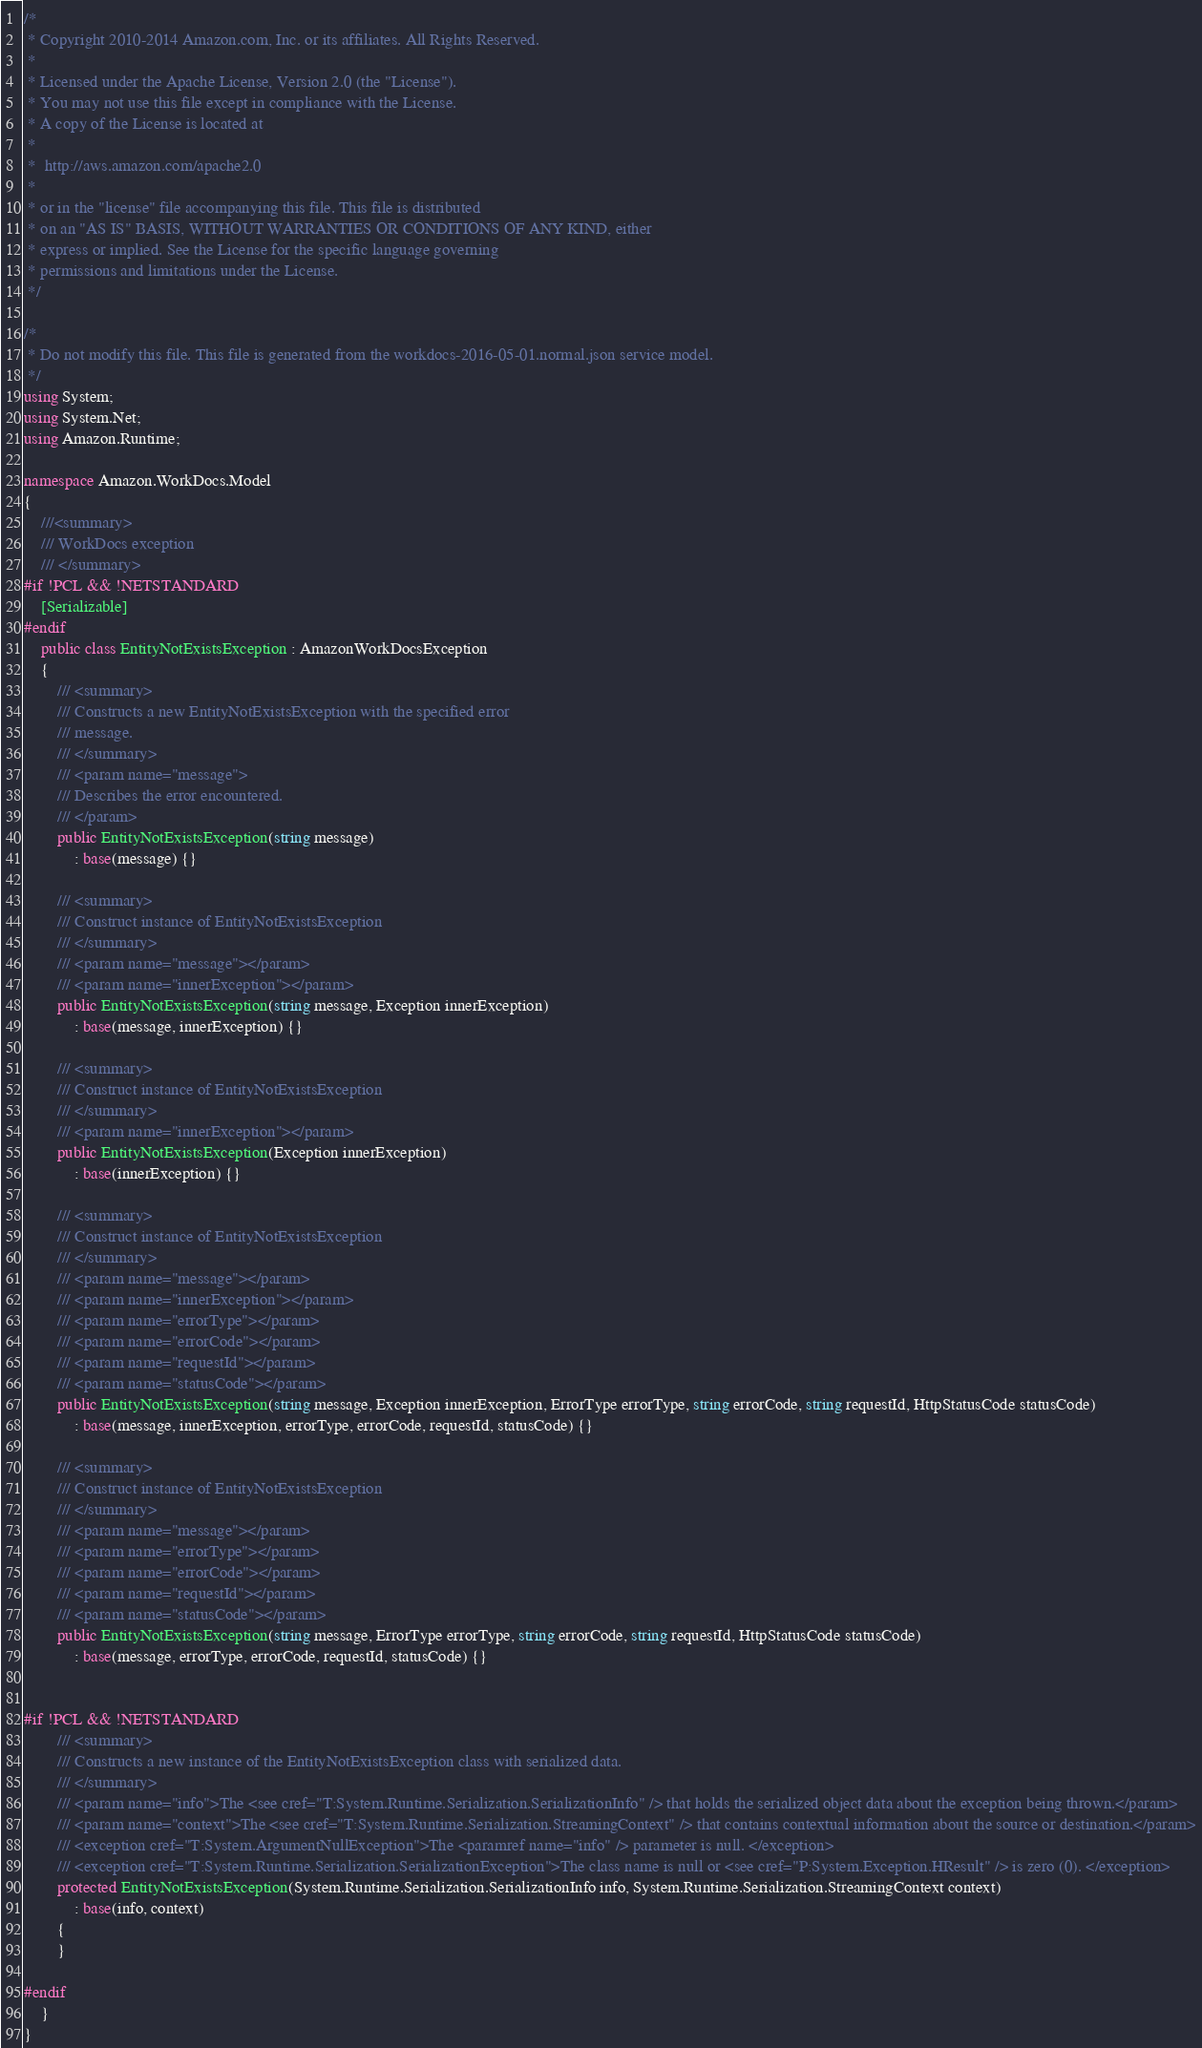<code> <loc_0><loc_0><loc_500><loc_500><_C#_>/*
 * Copyright 2010-2014 Amazon.com, Inc. or its affiliates. All Rights Reserved.
 * 
 * Licensed under the Apache License, Version 2.0 (the "License").
 * You may not use this file except in compliance with the License.
 * A copy of the License is located at
 * 
 *  http://aws.amazon.com/apache2.0
 * 
 * or in the "license" file accompanying this file. This file is distributed
 * on an "AS IS" BASIS, WITHOUT WARRANTIES OR CONDITIONS OF ANY KIND, either
 * express or implied. See the License for the specific language governing
 * permissions and limitations under the License.
 */

/*
 * Do not modify this file. This file is generated from the workdocs-2016-05-01.normal.json service model.
 */
using System;
using System.Net;
using Amazon.Runtime;

namespace Amazon.WorkDocs.Model
{
    ///<summary>
    /// WorkDocs exception
    /// </summary>
#if !PCL && !NETSTANDARD
    [Serializable]
#endif
    public class EntityNotExistsException : AmazonWorkDocsException 
    {
        /// <summary>
        /// Constructs a new EntityNotExistsException with the specified error
        /// message.
        /// </summary>
        /// <param name="message">
        /// Describes the error encountered.
        /// </param>
        public EntityNotExistsException(string message) 
            : base(message) {}
          
        /// <summary>
        /// Construct instance of EntityNotExistsException
        /// </summary>
        /// <param name="message"></param>
        /// <param name="innerException"></param>
        public EntityNotExistsException(string message, Exception innerException) 
            : base(message, innerException) {}
            
        /// <summary>
        /// Construct instance of EntityNotExistsException
        /// </summary>
        /// <param name="innerException"></param>
        public EntityNotExistsException(Exception innerException) 
            : base(innerException) {}
            
        /// <summary>
        /// Construct instance of EntityNotExistsException
        /// </summary>
        /// <param name="message"></param>
        /// <param name="innerException"></param>
        /// <param name="errorType"></param>
        /// <param name="errorCode"></param>
        /// <param name="requestId"></param>
        /// <param name="statusCode"></param>
        public EntityNotExistsException(string message, Exception innerException, ErrorType errorType, string errorCode, string requestId, HttpStatusCode statusCode) 
            : base(message, innerException, errorType, errorCode, requestId, statusCode) {}

        /// <summary>
        /// Construct instance of EntityNotExistsException
        /// </summary>
        /// <param name="message"></param>
        /// <param name="errorType"></param>
        /// <param name="errorCode"></param>
        /// <param name="requestId"></param>
        /// <param name="statusCode"></param>
        public EntityNotExistsException(string message, ErrorType errorType, string errorCode, string requestId, HttpStatusCode statusCode) 
            : base(message, errorType, errorCode, requestId, statusCode) {}


#if !PCL && !NETSTANDARD
        /// <summary>
        /// Constructs a new instance of the EntityNotExistsException class with serialized data.
        /// </summary>
        /// <param name="info">The <see cref="T:System.Runtime.Serialization.SerializationInfo" /> that holds the serialized object data about the exception being thrown.</param>
        /// <param name="context">The <see cref="T:System.Runtime.Serialization.StreamingContext" /> that contains contextual information about the source or destination.</param>
        /// <exception cref="T:System.ArgumentNullException">The <paramref name="info" /> parameter is null. </exception>
        /// <exception cref="T:System.Runtime.Serialization.SerializationException">The class name is null or <see cref="P:System.Exception.HResult" /> is zero (0). </exception>
        protected EntityNotExistsException(System.Runtime.Serialization.SerializationInfo info, System.Runtime.Serialization.StreamingContext context)
            : base(info, context)
        {
        }

#endif
    }
}</code> 